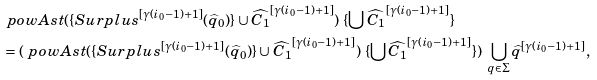<formula> <loc_0><loc_0><loc_500><loc_500>& \ p o w A s t ( \{ S u r p l u s ^ { [ \gamma ( i _ { 0 } - 1 ) + 1 ] } ( \widehat { q } _ { 0 } ) \} \cup \widehat { C _ { 1 } } ^ { [ \gamma ( i _ { 0 } - 1 ) + 1 ] } ) \ \{ \bigcup \widehat { C _ { 1 } } ^ { [ \gamma ( i _ { 0 } - 1 ) + 1 ] } \} \\ & = ( \ p o w A s t ( \{ S u r p l u s ^ { [ \gamma ( i _ { 0 } - 1 ) + 1 ] } ( \widehat { q } _ { 0 } ) \} \cup \widehat { C _ { 1 } } ^ { [ \gamma ( i _ { 0 } - 1 ) + 1 ] } ) \ \{ \bigcup \widehat { C _ { 1 } } ^ { [ \gamma ( i _ { 0 } - 1 ) + 1 ] } \} ) \ \bigcup _ { q \in \Sigma } \widehat { q } ^ { [ \gamma ( i _ { 0 } - 1 ) + 1 ] } ,</formula> 